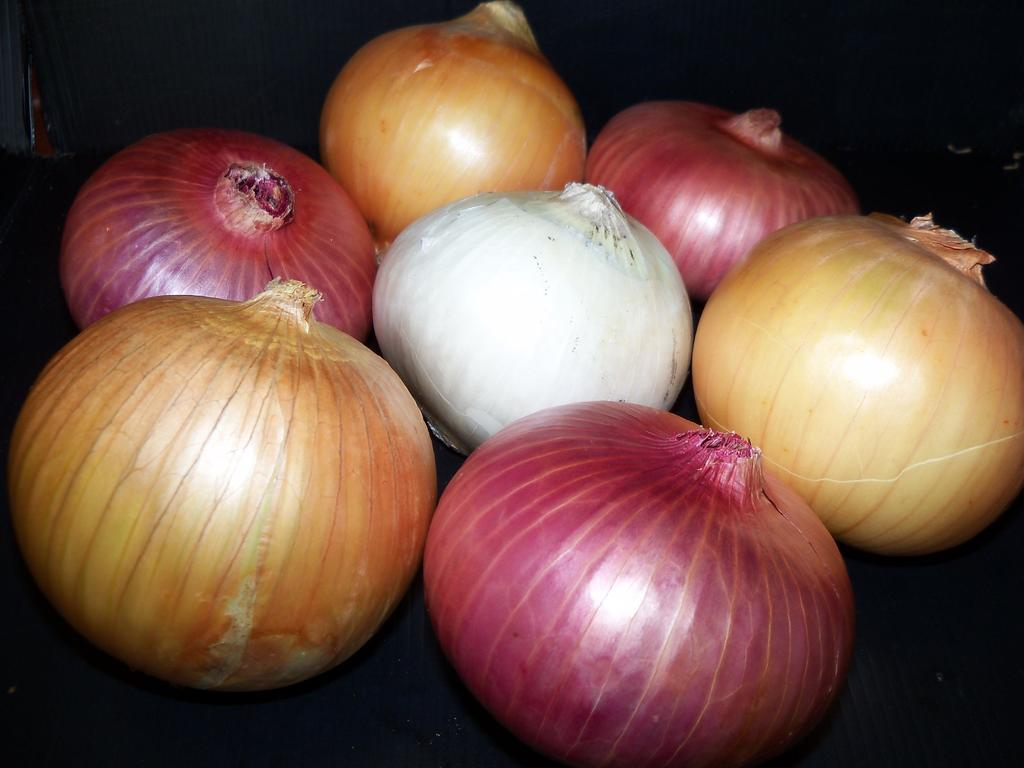What type of vegetables are present in the image? There are onions and garlic in the image. What surface are the onions and garlic placed on? The onions and garlic are placed on a black surface. How many crates of onions and garlic can be seen in the image? There is no crate present in the image; it only shows onions and garlic placed on a black surface. 